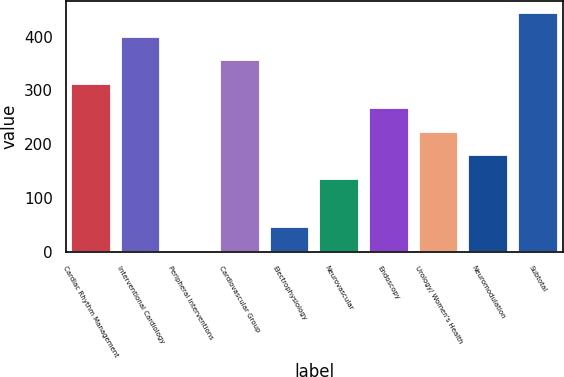Convert chart to OTSL. <chart><loc_0><loc_0><loc_500><loc_500><bar_chart><fcel>Cardiac Rhythm Management<fcel>Interventional Cardiology<fcel>Peripheral Interventions<fcel>Cardiovascular Group<fcel>Electrophysiology<fcel>Neurovascular<fcel>Endoscopy<fcel>Urology/ Women's Health<fcel>Neuromodulation<fcel>Subtotal<nl><fcel>311.4<fcel>399.8<fcel>2<fcel>355.6<fcel>46.2<fcel>134.6<fcel>267.2<fcel>223<fcel>178.8<fcel>444<nl></chart> 